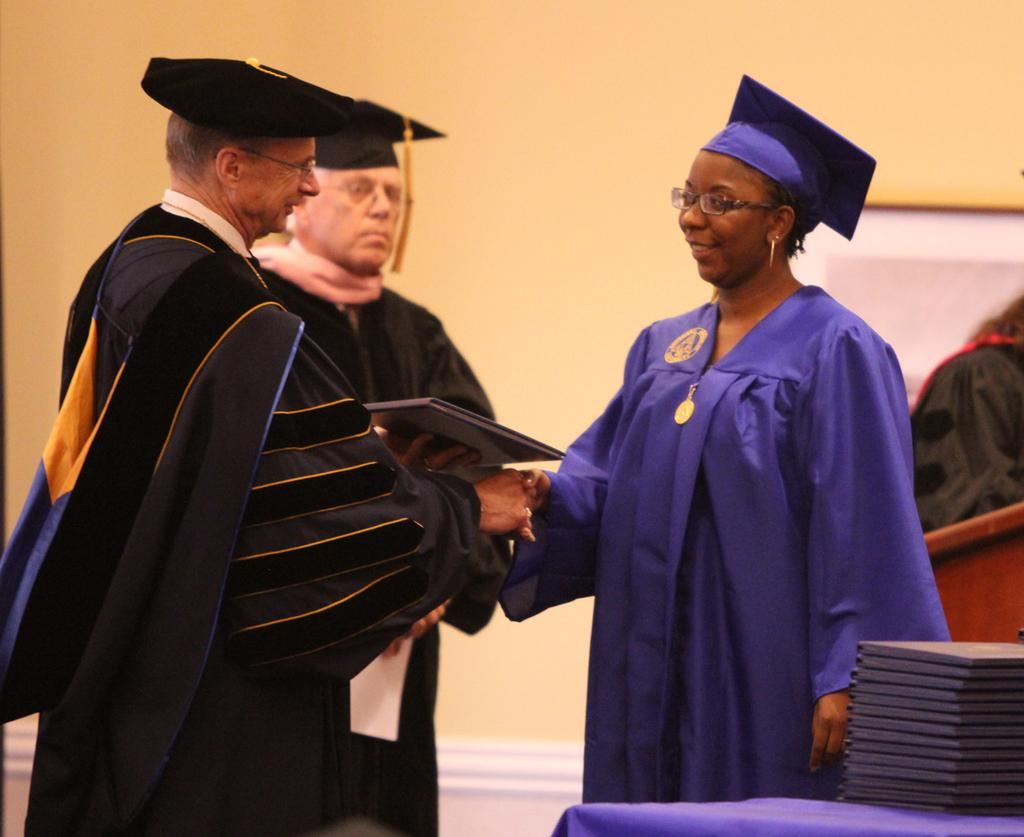Who or what is present in the image? There are people in the image. What are the people wearing? The people are wearing coats and hats. What can be seen on the table in the image? There are books placed on a table. What is the background of the image? There is a wall in the image. What type of flame can be seen coming from the books on the table? There is no flame present in the image; the books are not on fire. What sound does the bell make in the image? There is no bell present in the image, so it is not possible to determine the sound it might make. 